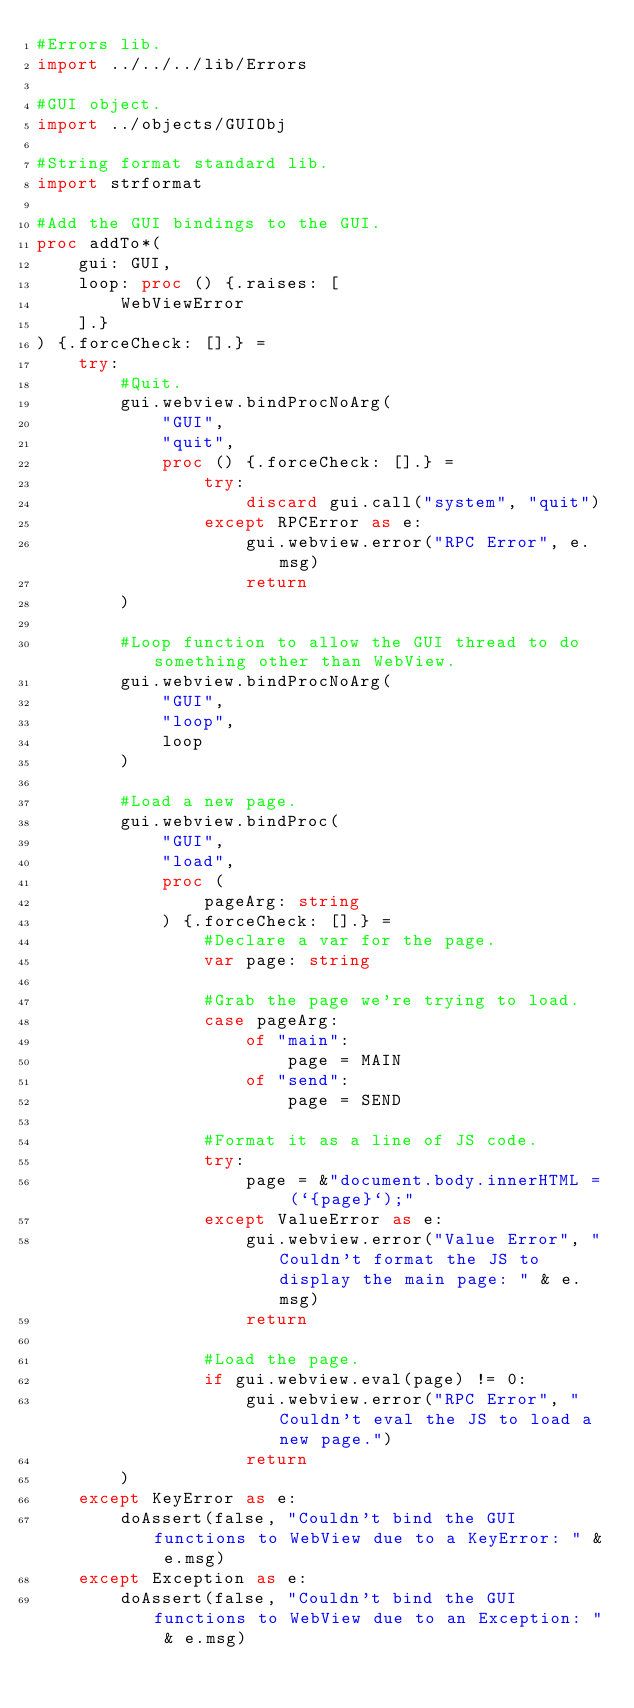<code> <loc_0><loc_0><loc_500><loc_500><_Nim_>#Errors lib.
import ../../../lib/Errors

#GUI object.
import ../objects/GUIObj

#String format standard lib.
import strformat

#Add the GUI bindings to the GUI.
proc addTo*(
    gui: GUI,
    loop: proc () {.raises: [
        WebViewError
    ].}
) {.forceCheck: [].} =
    try:
        #Quit.
        gui.webview.bindProcNoArg(
            "GUI",
            "quit",
            proc () {.forceCheck: [].} =
                try:
                    discard gui.call("system", "quit")
                except RPCError as e:
                    gui.webview.error("RPC Error", e.msg)
                    return
        )

        #Loop function to allow the GUI thread to do something other than WebView.
        gui.webview.bindProcNoArg(
            "GUI",
            "loop",
            loop
        )

        #Load a new page.
        gui.webview.bindProc(
            "GUI",
            "load",
            proc (
                pageArg: string
            ) {.forceCheck: [].} =
                #Declare a var for the page.
                var page: string

                #Grab the page we're trying to load.
                case pageArg:
                    of "main":
                        page = MAIN
                    of "send":
                        page = SEND
                
                #Format it as a line of JS code.
                try:
                    page = &"document.body.innerHTML = (`{page}`);"
                except ValueError as e:
                    gui.webview.error("Value Error", "Couldn't format the JS to display the main page: " & e.msg)
                    return

                #Load the page.
                if gui.webview.eval(page) != 0:
                    gui.webview.error("RPC Error", "Couldn't eval the JS to load a new page.")
                    return
        )
    except KeyError as e:
        doAssert(false, "Couldn't bind the GUI functions to WebView due to a KeyError: " & e.msg)
    except Exception as e:
        doAssert(false, "Couldn't bind the GUI functions to WebView due to an Exception: " & e.msg)
</code> 